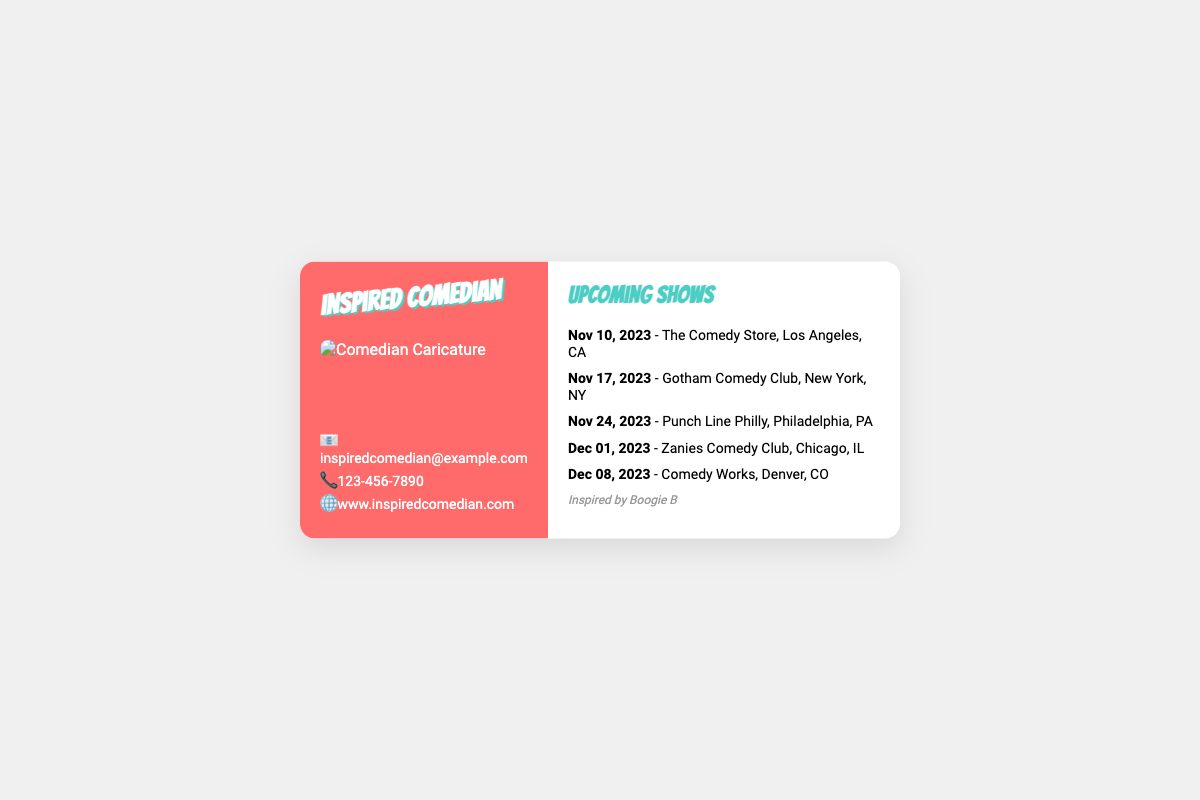What is the first upcoming show date? The first upcoming show date listed in the document is November 10, 2023.
Answer: November 10, 2023 Where is the show on December 1, 2023? The venue for the show on December 1, 2023, is Zanies Comedy Club in Chicago, IL.
Answer: Zanies Comedy Club, Chicago, IL How many shows are listed in total? The document lists a total of five upcoming shows.
Answer: Five What is the email address provided? The email address provided in the document is inspiredcomedian@example.com.
Answer: inspiredcomedian@example.com Which comedy club is mentioned for the show on November 17, 2023? The comedy club listed for the show on November 17, 2023, is Gotham Comedy Club in New York, NY.
Answer: Gotham Comedy Club, New York, NY What theme or inspiration is noted on the business card? The card mentions it is inspired by Boogie B.
Answer: Inspired by Boogie B 